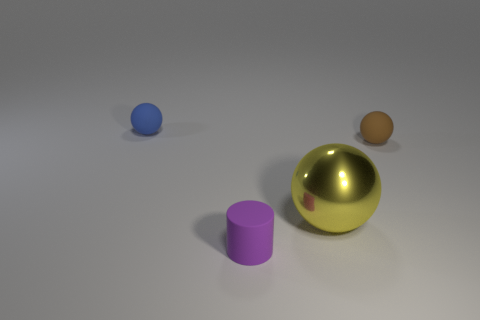Add 1 purple things. How many objects exist? 5 Subtract all cylinders. How many objects are left? 3 Subtract all large brown metal things. Subtract all large yellow objects. How many objects are left? 3 Add 4 tiny objects. How many tiny objects are left? 7 Add 1 small matte cylinders. How many small matte cylinders exist? 2 Subtract 0 red spheres. How many objects are left? 4 